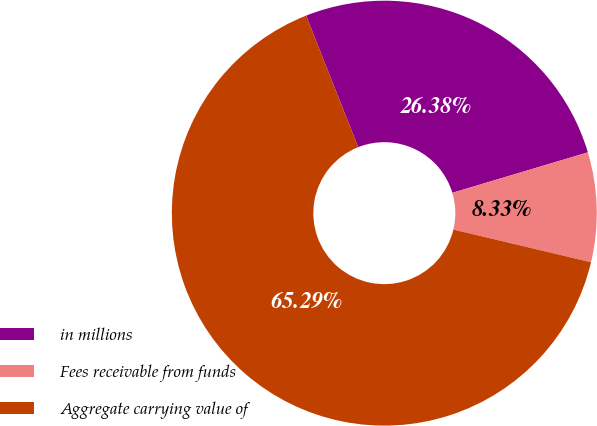<chart> <loc_0><loc_0><loc_500><loc_500><pie_chart><fcel>in millions<fcel>Fees receivable from funds<fcel>Aggregate carrying value of<nl><fcel>26.38%<fcel>8.33%<fcel>65.29%<nl></chart> 